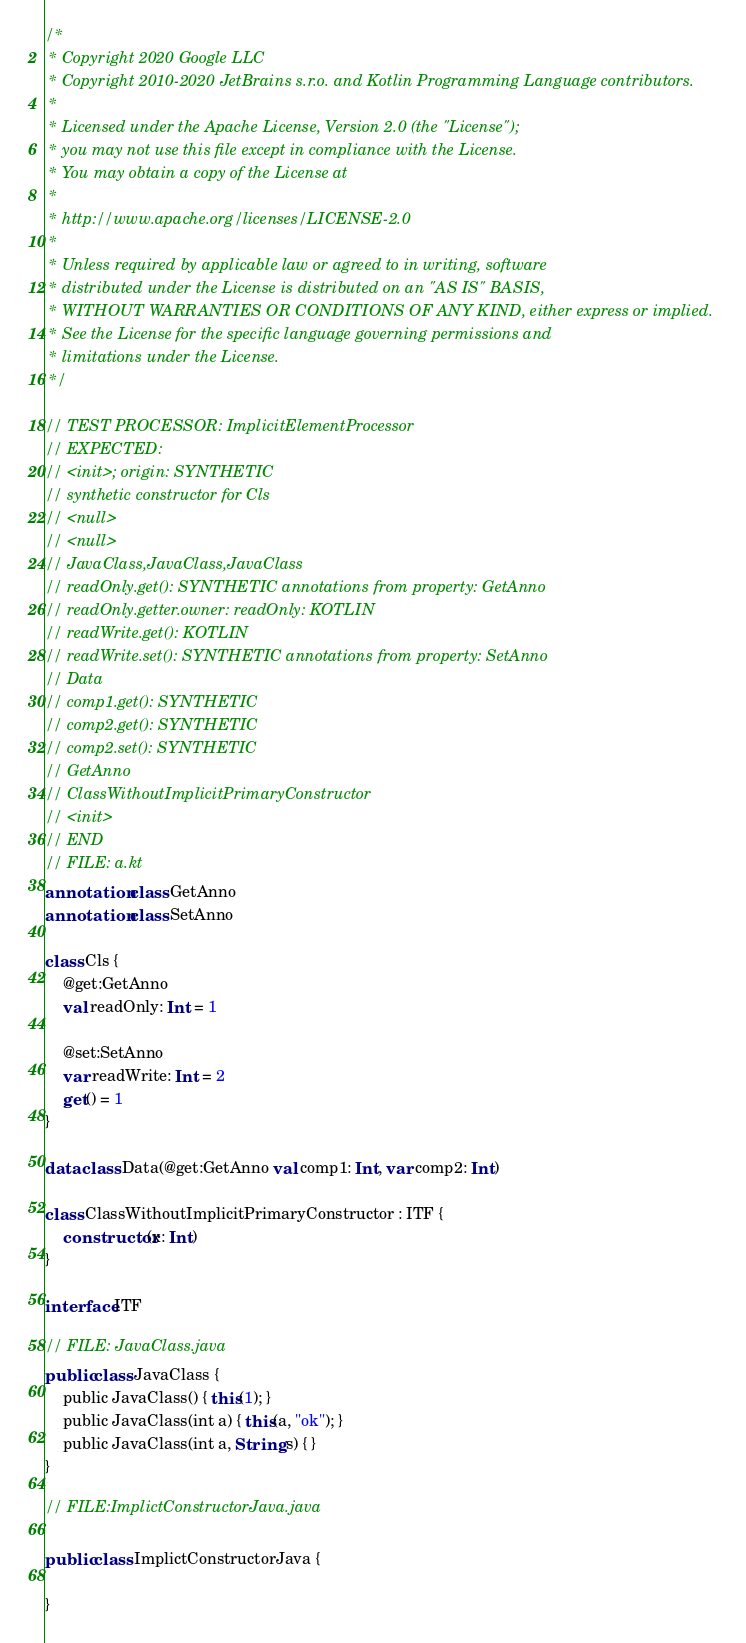Convert code to text. <code><loc_0><loc_0><loc_500><loc_500><_Kotlin_>/*
 * Copyright 2020 Google LLC
 * Copyright 2010-2020 JetBrains s.r.o. and Kotlin Programming Language contributors.
 *
 * Licensed under the Apache License, Version 2.0 (the "License");
 * you may not use this file except in compliance with the License.
 * You may obtain a copy of the License at
 *
 * http://www.apache.org/licenses/LICENSE-2.0
 *
 * Unless required by applicable law or agreed to in writing, software
 * distributed under the License is distributed on an "AS IS" BASIS,
 * WITHOUT WARRANTIES OR CONDITIONS OF ANY KIND, either express or implied.
 * See the License for the specific language governing permissions and
 * limitations under the License.
 */

// TEST PROCESSOR: ImplicitElementProcessor
// EXPECTED:
// <init>; origin: SYNTHETIC
// synthetic constructor for Cls
// <null>
// <null>
// JavaClass,JavaClass,JavaClass
// readOnly.get(): SYNTHETIC annotations from property: GetAnno
// readOnly.getter.owner: readOnly: KOTLIN
// readWrite.get(): KOTLIN
// readWrite.set(): SYNTHETIC annotations from property: SetAnno
// Data
// comp1.get(): SYNTHETIC
// comp2.get(): SYNTHETIC
// comp2.set(): SYNTHETIC
// GetAnno
// ClassWithoutImplicitPrimaryConstructor
// <init>
// END
// FILE: a.kt
annotation class GetAnno
annotation class SetAnno

class Cls {
    @get:GetAnno
    val readOnly: Int = 1

    @set:SetAnno
    var readWrite: Int = 2
    get() = 1
}

data class Data(@get:GetAnno val comp1: Int, var comp2: Int)

class ClassWithoutImplicitPrimaryConstructor : ITF {
    constructor(x: Int)
}

interface ITF

// FILE: JavaClass.java
public class JavaClass {
    public JavaClass() { this(1); }
    public JavaClass(int a) { this(a, "ok"); }
    public JavaClass(int a, String s) { }
}

// FILE:ImplictConstructorJava.java

public class ImplictConstructorJava {

}</code> 